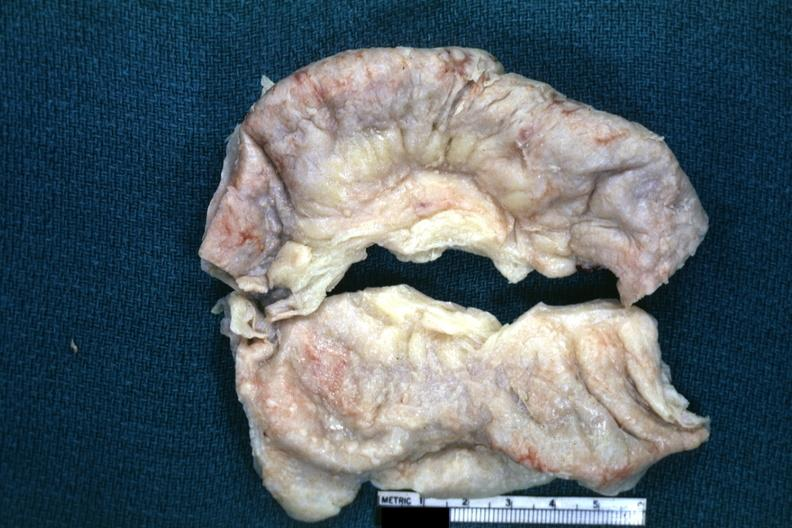what is present?
Answer the question using a single word or phrase. Abdomen 